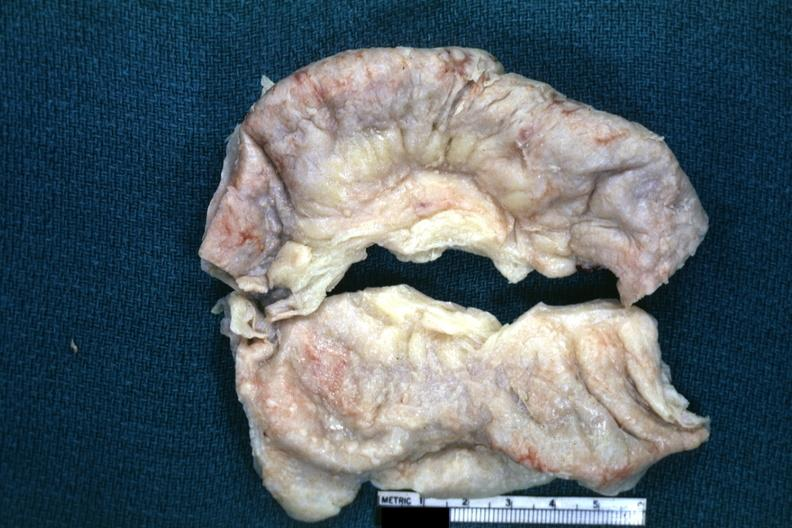what is present?
Answer the question using a single word or phrase. Abdomen 